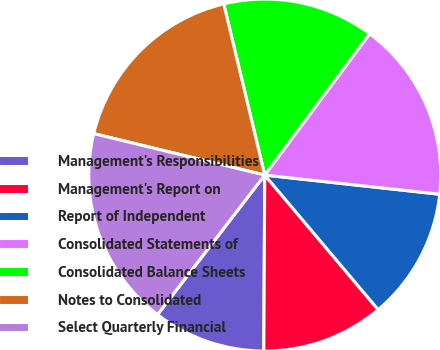Convert chart to OTSL. <chart><loc_0><loc_0><loc_500><loc_500><pie_chart><fcel>Management's Responsibilities<fcel>Management's Report on<fcel>Report of Independent<fcel>Consolidated Statements of<fcel>Consolidated Balance Sheets<fcel>Notes to Consolidated<fcel>Select Quarterly Financial<nl><fcel>10.34%<fcel>11.23%<fcel>12.12%<fcel>16.58%<fcel>13.9%<fcel>17.47%<fcel>18.36%<nl></chart> 